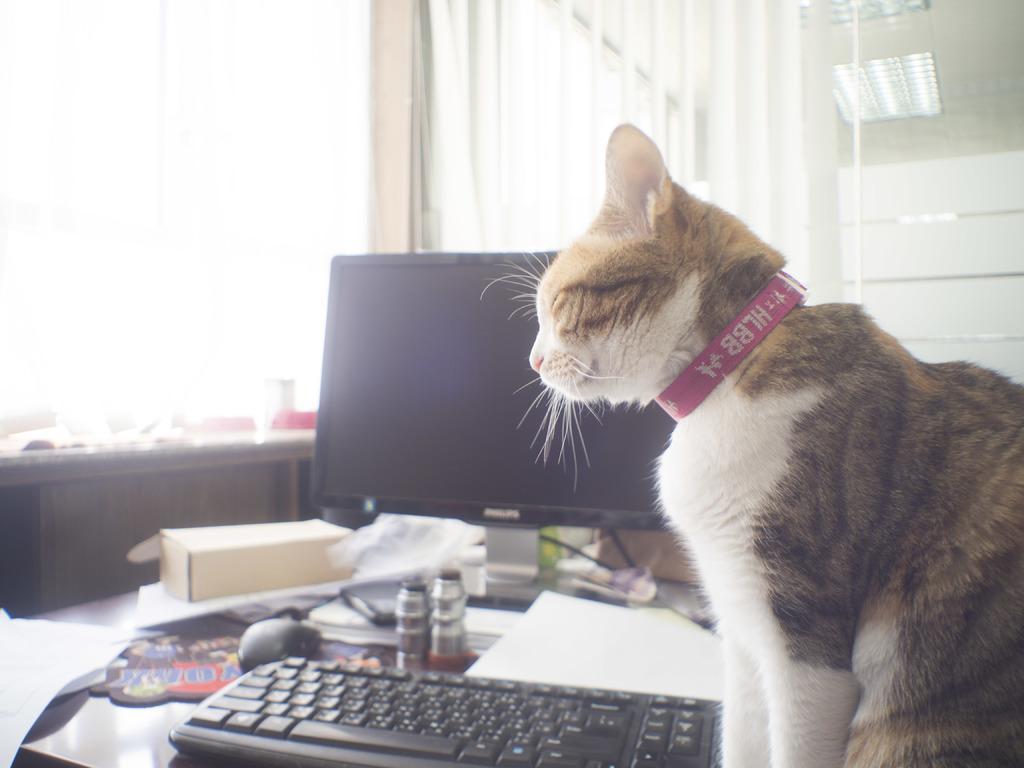In one or two sentences, can you explain what this image depicts? Here we can see a cat, a keyboard, a monitor, a mouse, books and papers all present on a table 